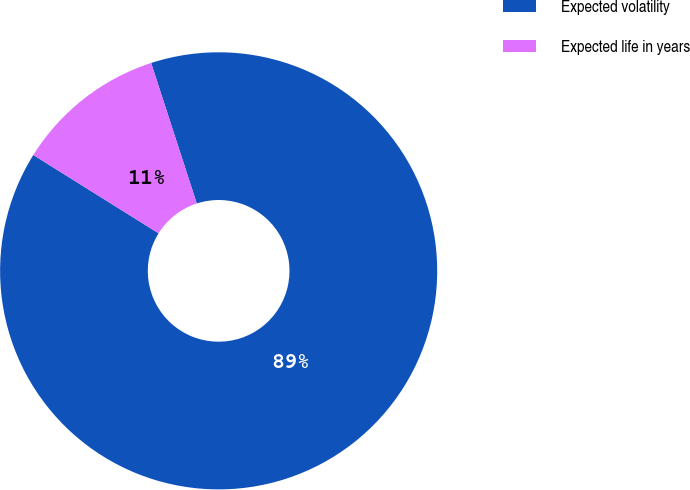Convert chart to OTSL. <chart><loc_0><loc_0><loc_500><loc_500><pie_chart><fcel>Expected volatility<fcel>Expected life in years<nl><fcel>88.89%<fcel>11.11%<nl></chart> 